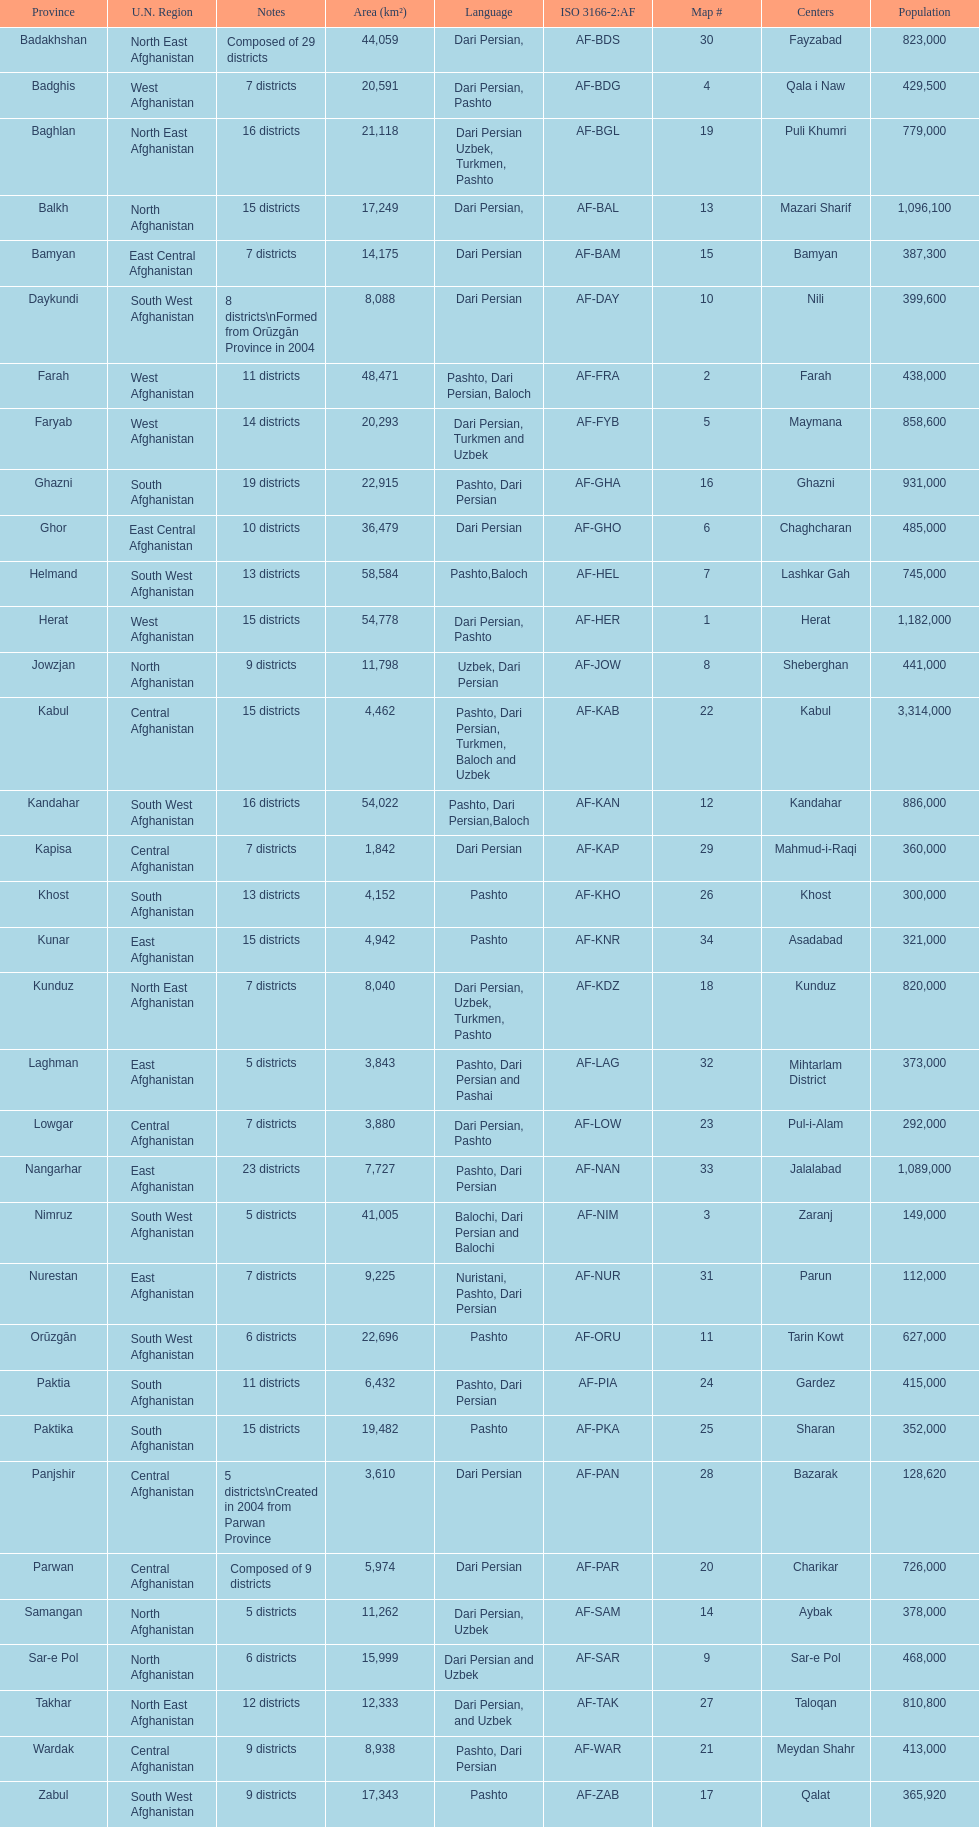Herat has a population of 1,182,000, can you list their languages Dari Persian, Pashto. 